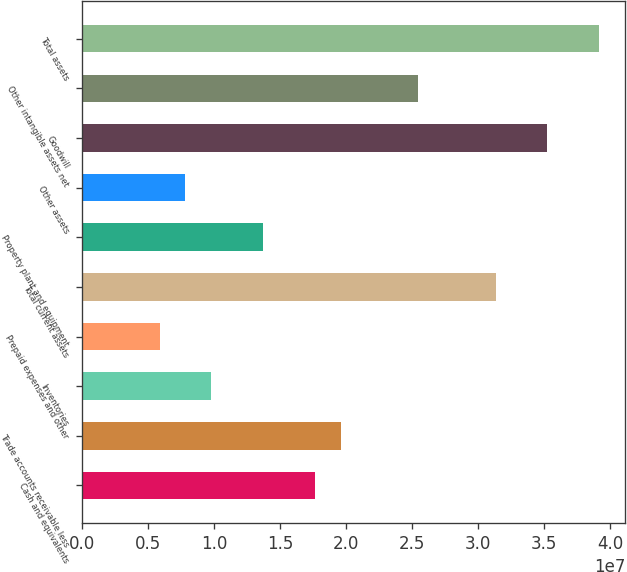Convert chart. <chart><loc_0><loc_0><loc_500><loc_500><bar_chart><fcel>Cash and equivalents<fcel>Trade accounts receivable less<fcel>Inventories<fcel>Prepaid expenses and other<fcel>Total current assets<fcel>Property plant and equipment<fcel>Other assets<fcel>Goodwill<fcel>Other intangible assets net<fcel>Total assets<nl><fcel>1.76362e+07<fcel>1.95954e+07<fcel>9.7995e+06<fcel>5.88114e+06<fcel>3.13505e+07<fcel>1.37179e+07<fcel>7.84032e+06<fcel>3.52689e+07<fcel>2.5473e+07<fcel>3.91873e+07<nl></chart> 